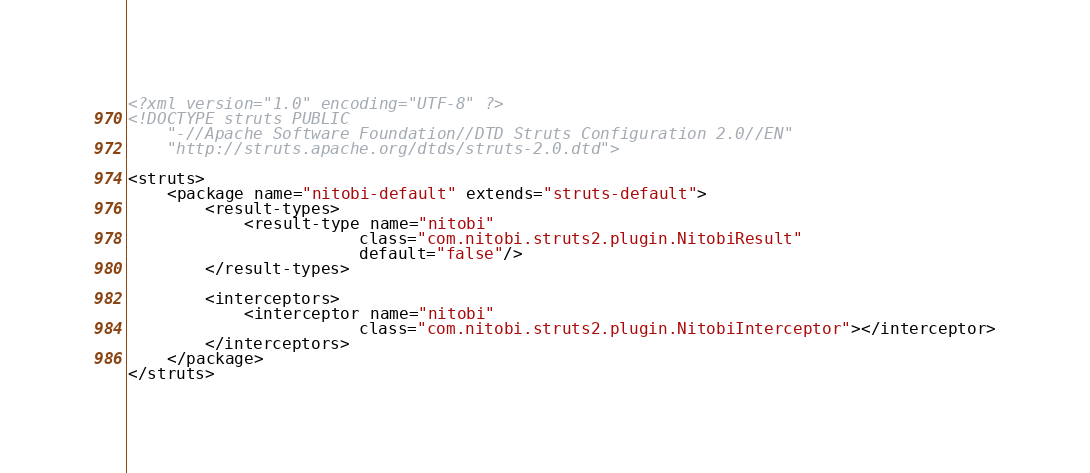Convert code to text. <code><loc_0><loc_0><loc_500><loc_500><_XML_><?xml version="1.0" encoding="UTF-8" ?>
<!DOCTYPE struts PUBLIC
    "-//Apache Software Foundation//DTD Struts Configuration 2.0//EN"
    "http://struts.apache.org/dtds/struts-2.0.dtd">

<struts>
    <package name="nitobi-default" extends="struts-default">
        <result-types>
            <result-type name="nitobi" 
            			class="com.nitobi.struts2.plugin.NitobiResult"
            			default="false"/>
        </result-types>
        
        <interceptors>
        	<interceptor name="nitobi" 
        				class="com.nitobi.struts2.plugin.NitobiInterceptor"></interceptor>
        </interceptors>
    </package>
</struts></code> 